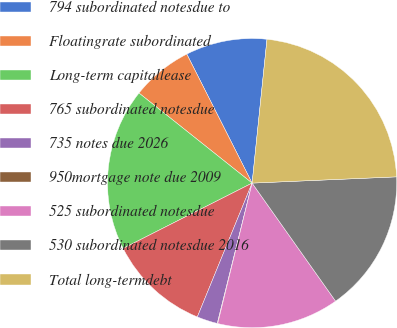<chart> <loc_0><loc_0><loc_500><loc_500><pie_chart><fcel>794 subordinated notesdue to<fcel>Floatingrate subordinated<fcel>Long-term capitallease<fcel>765 subordinated notesdue<fcel>735 notes due 2026<fcel>950mortgage note due 2009<fcel>525 subordinated notesdue<fcel>530 subordinated notesdue 2016<fcel>Total long-termdebt<nl><fcel>9.1%<fcel>6.84%<fcel>18.15%<fcel>11.36%<fcel>2.31%<fcel>0.05%<fcel>13.62%<fcel>15.89%<fcel>22.67%<nl></chart> 